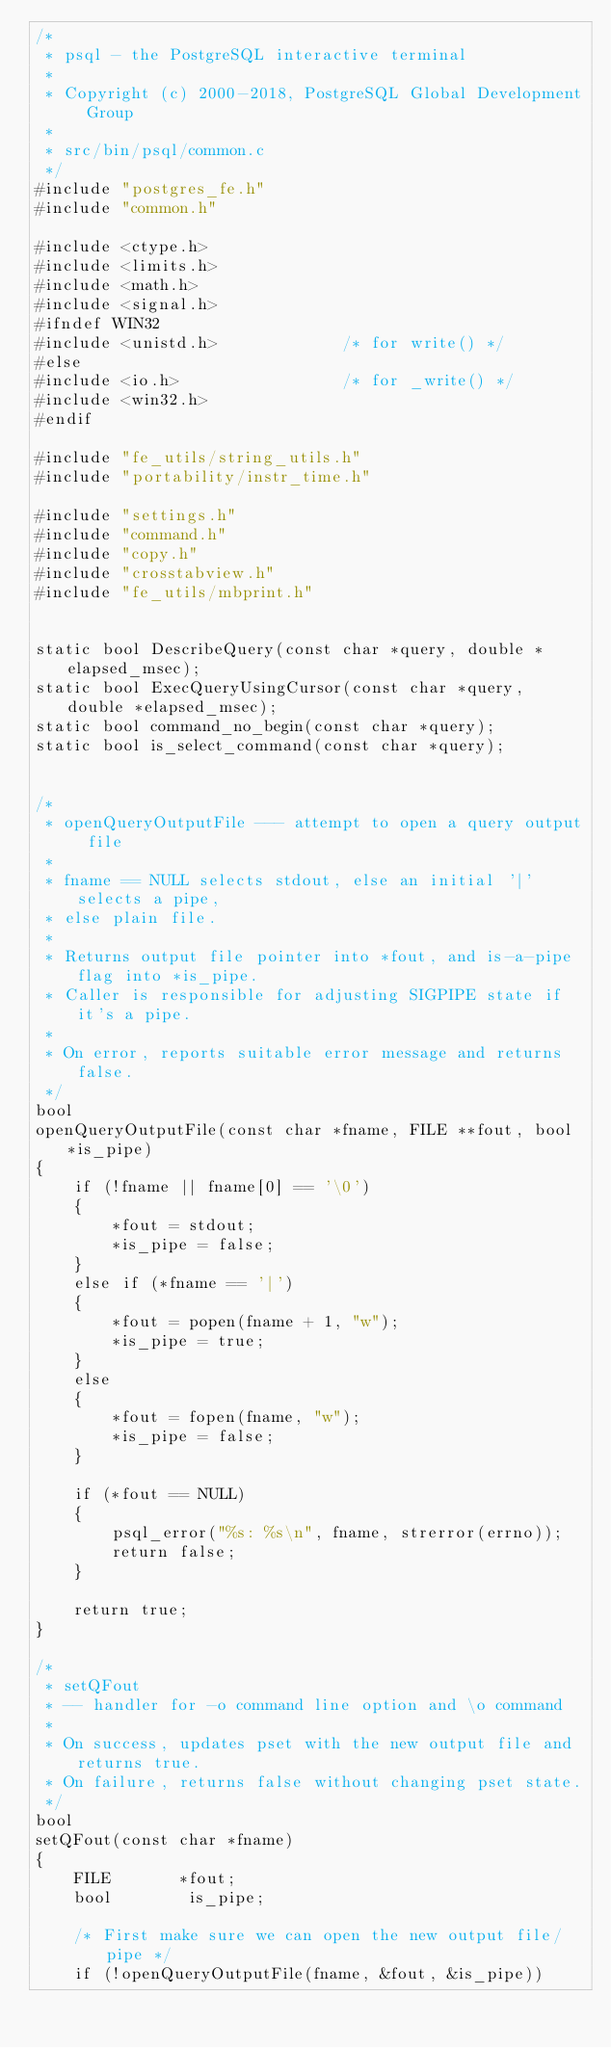<code> <loc_0><loc_0><loc_500><loc_500><_C_>/*
 * psql - the PostgreSQL interactive terminal
 *
 * Copyright (c) 2000-2018, PostgreSQL Global Development Group
 *
 * src/bin/psql/common.c
 */
#include "postgres_fe.h"
#include "common.h"

#include <ctype.h>
#include <limits.h>
#include <math.h>
#include <signal.h>
#ifndef WIN32
#include <unistd.h>				/* for write() */
#else
#include <io.h>					/* for _write() */
#include <win32.h>
#endif

#include "fe_utils/string_utils.h"
#include "portability/instr_time.h"

#include "settings.h"
#include "command.h"
#include "copy.h"
#include "crosstabview.h"
#include "fe_utils/mbprint.h"


static bool DescribeQuery(const char *query, double *elapsed_msec);
static bool ExecQueryUsingCursor(const char *query, double *elapsed_msec);
static bool command_no_begin(const char *query);
static bool is_select_command(const char *query);


/*
 * openQueryOutputFile --- attempt to open a query output file
 *
 * fname == NULL selects stdout, else an initial '|' selects a pipe,
 * else plain file.
 *
 * Returns output file pointer into *fout, and is-a-pipe flag into *is_pipe.
 * Caller is responsible for adjusting SIGPIPE state if it's a pipe.
 *
 * On error, reports suitable error message and returns false.
 */
bool
openQueryOutputFile(const char *fname, FILE **fout, bool *is_pipe)
{
	if (!fname || fname[0] == '\0')
	{
		*fout = stdout;
		*is_pipe = false;
	}
	else if (*fname == '|')
	{
		*fout = popen(fname + 1, "w");
		*is_pipe = true;
	}
	else
	{
		*fout = fopen(fname, "w");
		*is_pipe = false;
	}

	if (*fout == NULL)
	{
		psql_error("%s: %s\n", fname, strerror(errno));
		return false;
	}

	return true;
}

/*
 * setQFout
 * -- handler for -o command line option and \o command
 *
 * On success, updates pset with the new output file and returns true.
 * On failure, returns false without changing pset state.
 */
bool
setQFout(const char *fname)
{
	FILE	   *fout;
	bool		is_pipe;

	/* First make sure we can open the new output file/pipe */
	if (!openQueryOutputFile(fname, &fout, &is_pipe))</code> 